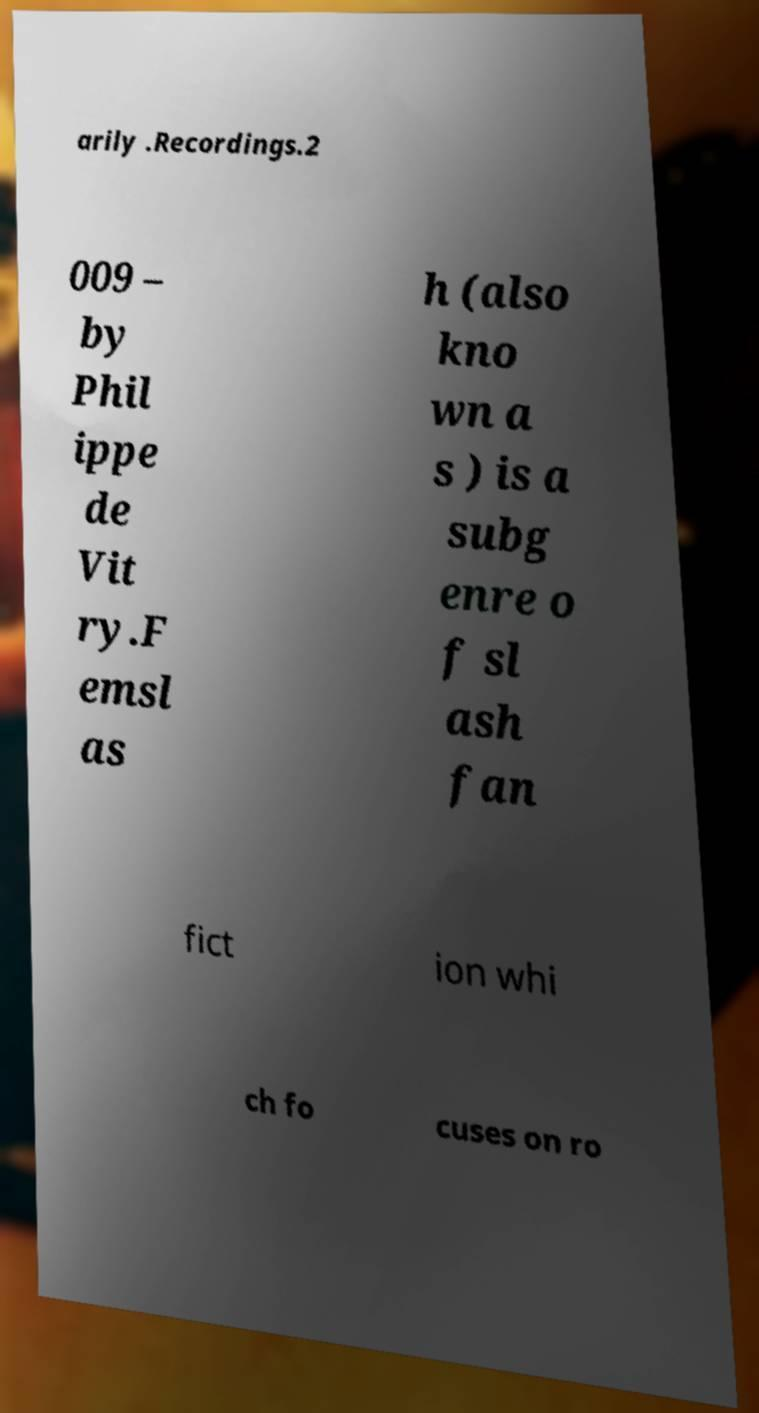Could you extract and type out the text from this image? arily .Recordings.2 009 – by Phil ippe de Vit ry.F emsl as h (also kno wn a s ) is a subg enre o f sl ash fan fict ion whi ch fo cuses on ro 